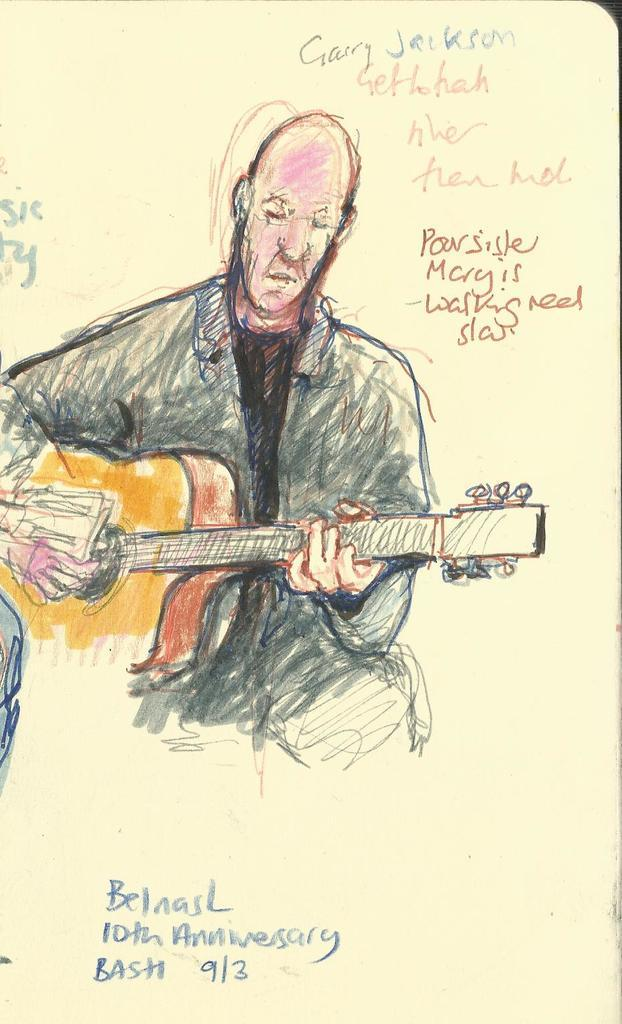What type of artwork is depicted in the image? The image is a painting. Can you describe the subject of the painting? There is a person in the painting. What is the person holding in the painting? The person is holding a guitar. What type of riddle is the person in the painting trying to solve? There is no riddle present in the painting; it simply depicts a person holding a guitar. 